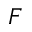<formula> <loc_0><loc_0><loc_500><loc_500>F</formula> 